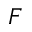<formula> <loc_0><loc_0><loc_500><loc_500>F</formula> 